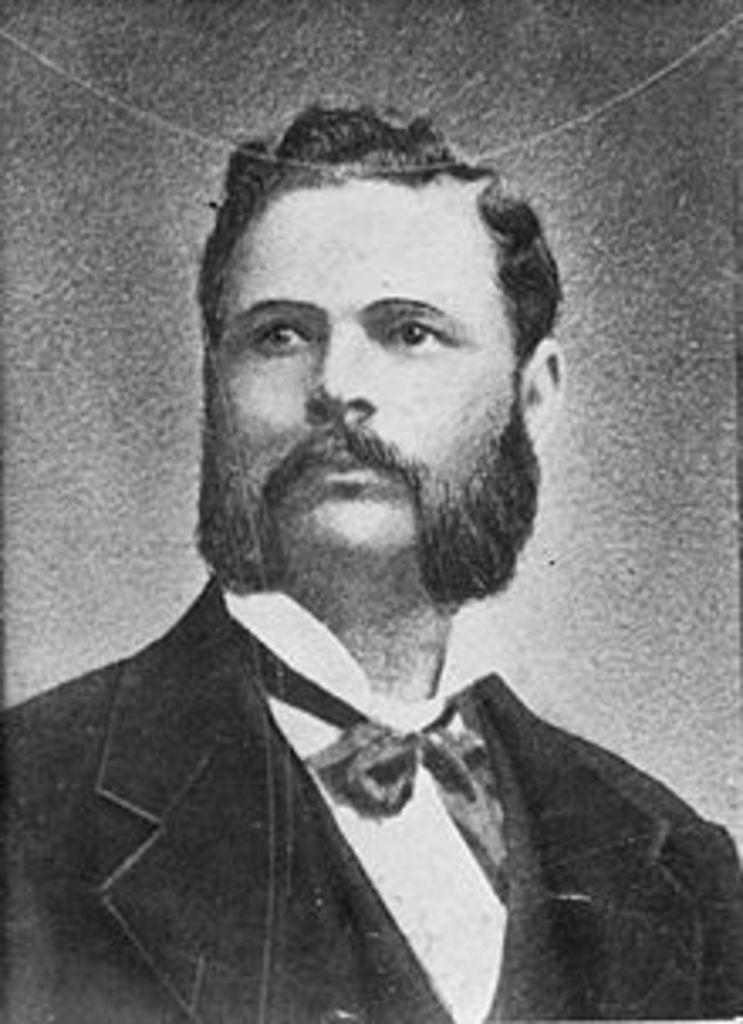Who is present in the image? There is a man in the image. What is the man wearing in the image? The man is wearing a coat and a bow tie in the image. What is the color scheme of the image? The image is black and white. What type of straw is the man holding in the image? There is no straw present in the image. What is the man's position in the image? The provided facts do not give information about the man's position in the image. 